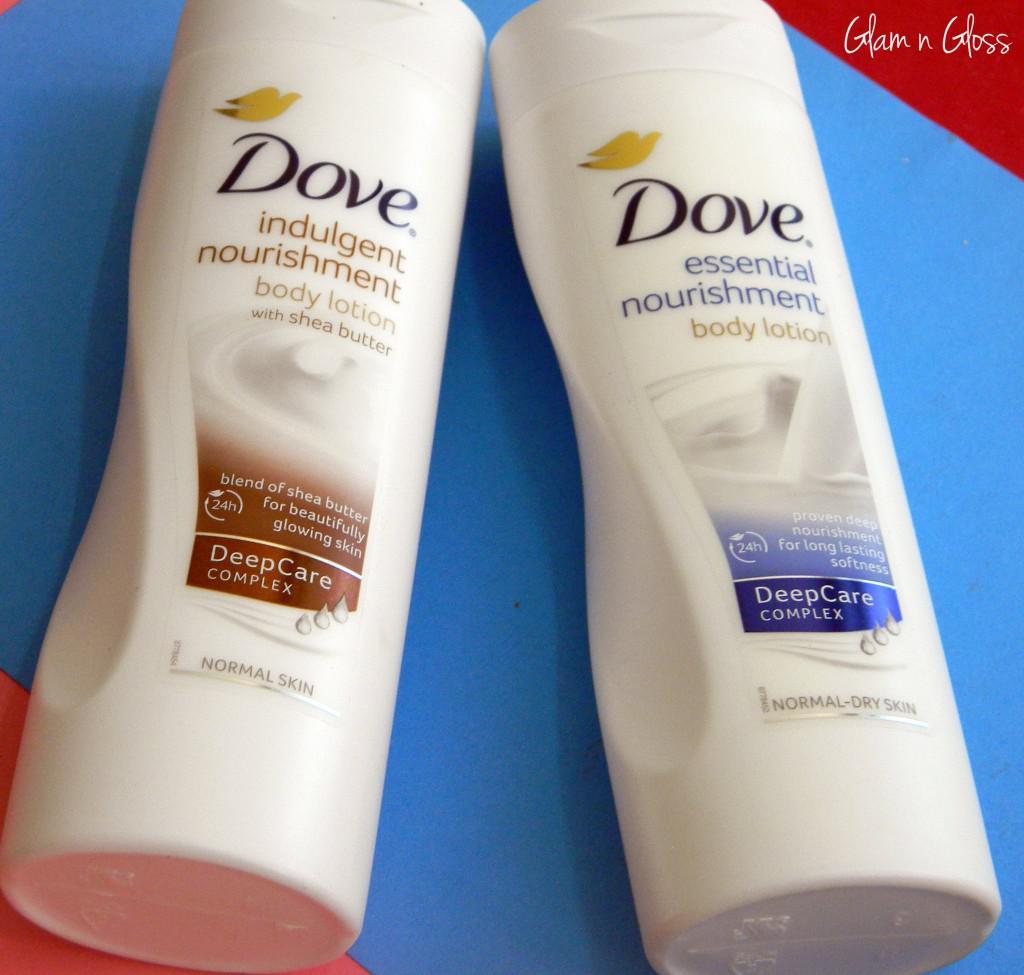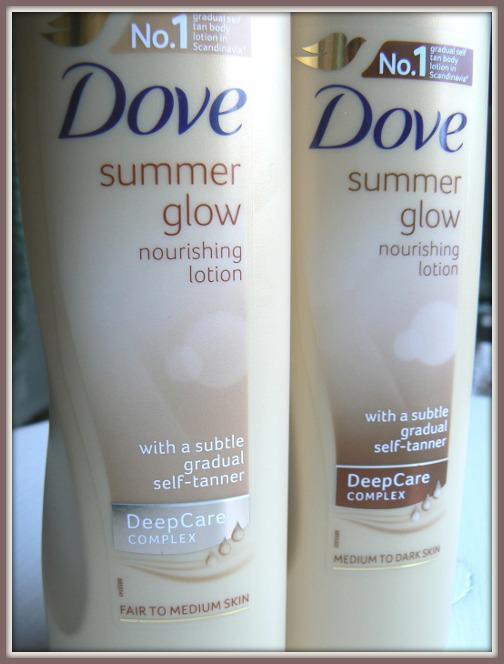The first image is the image on the left, the second image is the image on the right. For the images displayed, is the sentence "The left image shows two containers labeled, """"Dove.""""" factually correct? Answer yes or no. Yes. The first image is the image on the left, the second image is the image on the right. For the images shown, is this caption "There is at least one product shown with its corresponding box." true? Answer yes or no. No. 